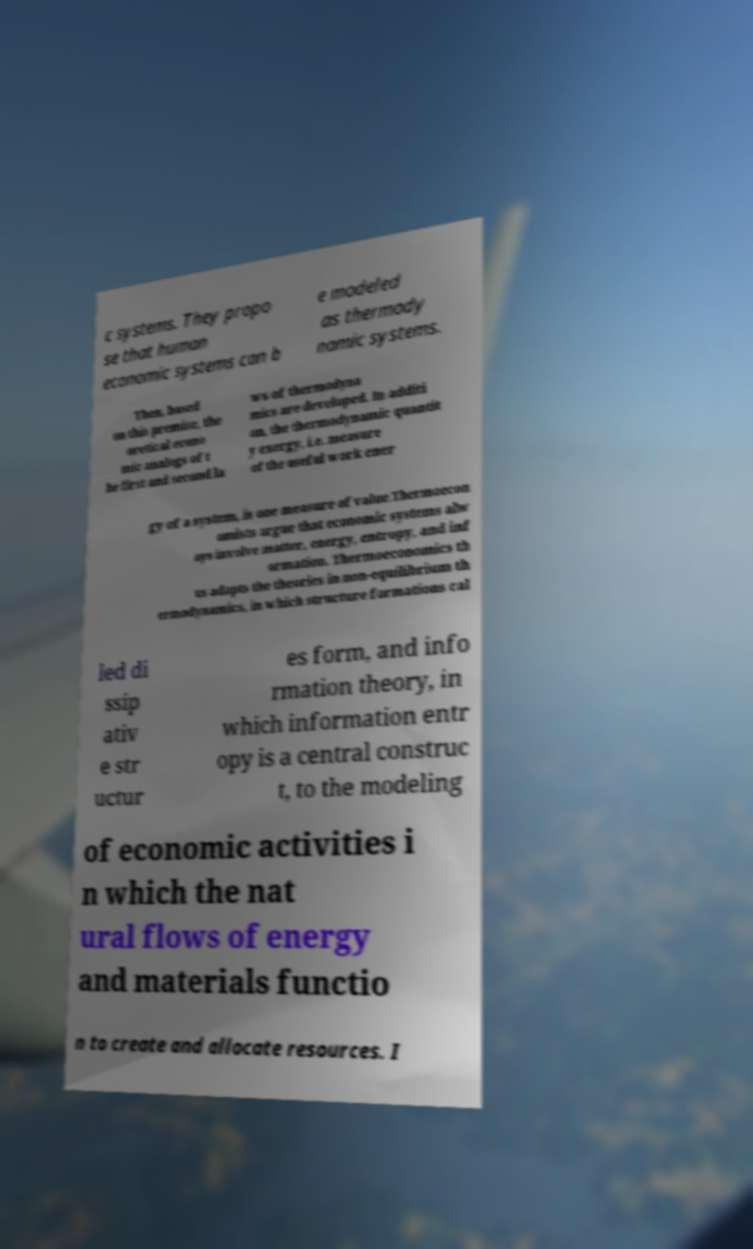For documentation purposes, I need the text within this image transcribed. Could you provide that? c systems. They propo se that human economic systems can b e modeled as thermody namic systems. Then, based on this premise, the oretical econo mic analogs of t he first and second la ws of thermodyna mics are developed. In additi on, the thermodynamic quantit y exergy, i.e. measure of the useful work ener gy of a system, is one measure of value.Thermoecon omists argue that economic systems alw ays involve matter, energy, entropy, and inf ormation. Thermoeconomics th us adapts the theories in non-equilibrium th ermodynamics, in which structure formations cal led di ssip ativ e str uctur es form, and info rmation theory, in which information entr opy is a central construc t, to the modeling of economic activities i n which the nat ural flows of energy and materials functio n to create and allocate resources. I 